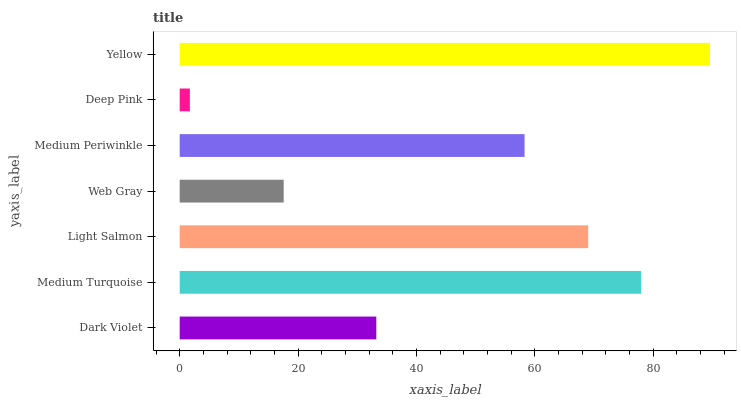Is Deep Pink the minimum?
Answer yes or no. Yes. Is Yellow the maximum?
Answer yes or no. Yes. Is Medium Turquoise the minimum?
Answer yes or no. No. Is Medium Turquoise the maximum?
Answer yes or no. No. Is Medium Turquoise greater than Dark Violet?
Answer yes or no. Yes. Is Dark Violet less than Medium Turquoise?
Answer yes or no. Yes. Is Dark Violet greater than Medium Turquoise?
Answer yes or no. No. Is Medium Turquoise less than Dark Violet?
Answer yes or no. No. Is Medium Periwinkle the high median?
Answer yes or no. Yes. Is Medium Periwinkle the low median?
Answer yes or no. Yes. Is Web Gray the high median?
Answer yes or no. No. Is Medium Turquoise the low median?
Answer yes or no. No. 